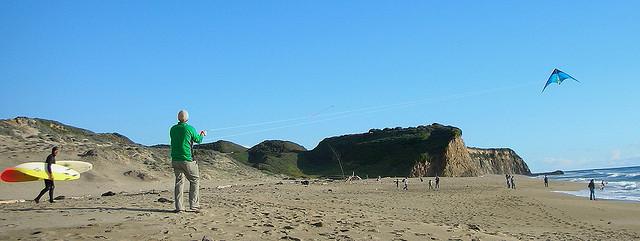What is the person on the right doing?
Answer briefly. Flying kite. Is it cloudy?
Short answer required. No. What is the person on the left carrying?
Be succinct. Surfboards. 